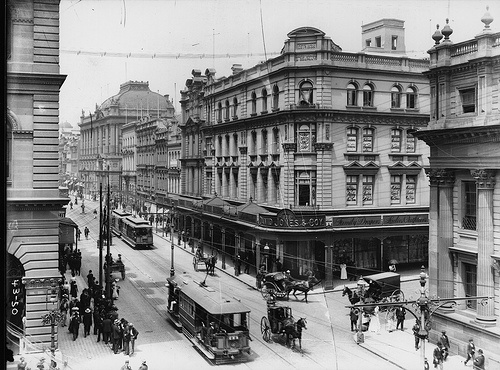Describe the objects in this image and their specific colors. I can see train in black, darkgray, gray, and lightgray tones, people in black, darkgray, gray, and lightgray tones, train in black, gray, lightgray, and darkgray tones, horse in black, gray, darkgray, and lightgray tones, and horse in black, gray, darkgray, and lightgray tones in this image. 